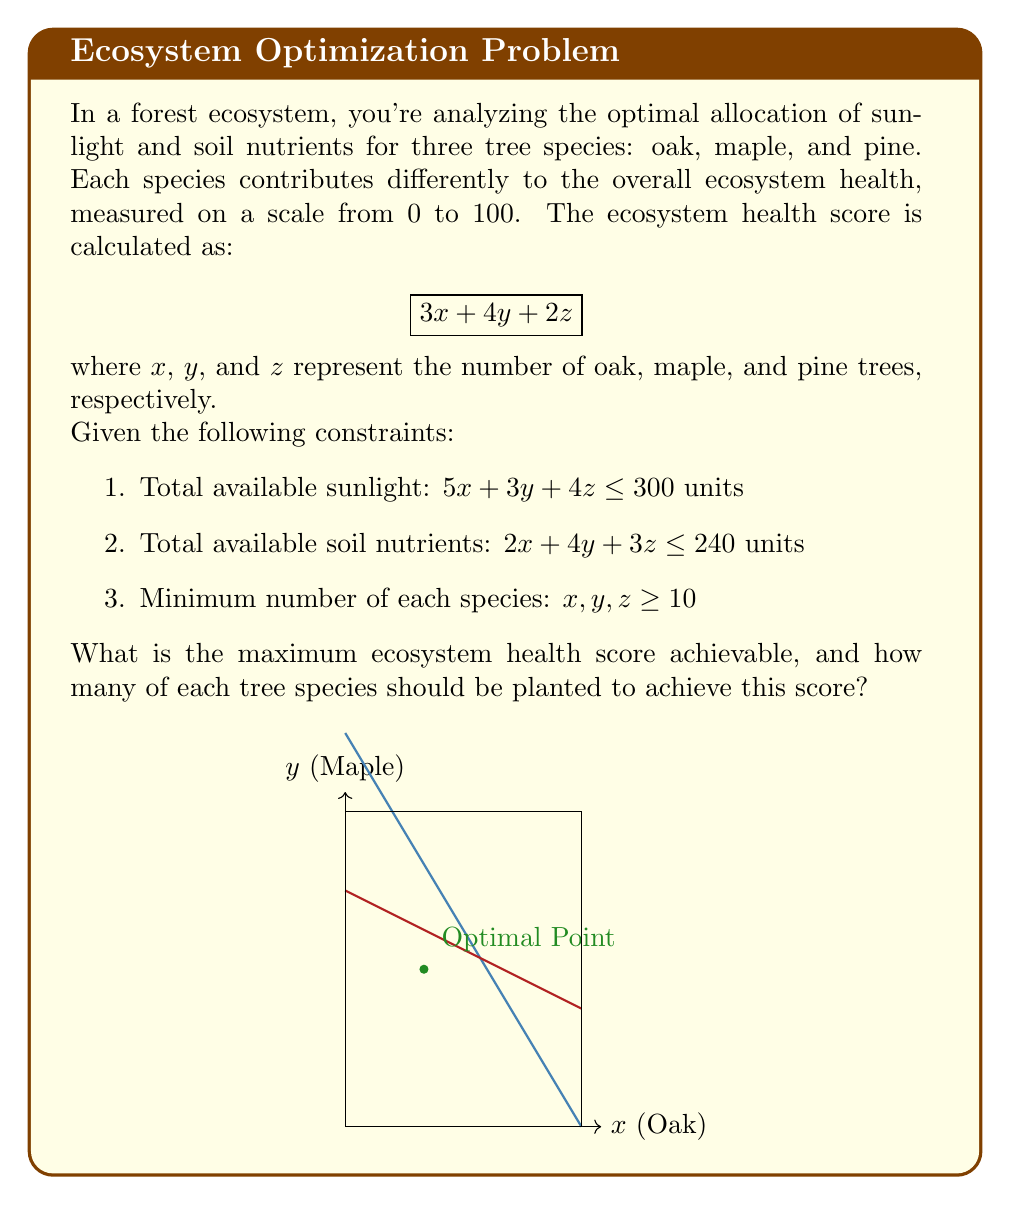Could you help me with this problem? To solve this linear programming problem, we'll follow these steps:

1) First, let's set up the objective function and constraints:

   Maximize: $3x + 4y + 2z$
   Subject to:
   $5x + 3y + 4z \leq 300$
   $2x + 4y + 3z \leq 240$
   $x, y, z \geq 10$

2) We can solve this using the simplex method, but for this explanation, we'll use a graphical approach focusing on the $x-y$ plane (oak-maple).

3) Let's graph the constraints:
   For $z = 10$ (minimum number of pine trees):
   $5x + 3y \leq 260$
   $2x + 4y \leq 210$

4) The feasible region is the area that satisfies all constraints. The optimal solution will be at one of the corners of this region.

5) The corners of the feasible region are:
   (10, 10), (20, 40), (42, 10), (10, 45)

6) Let's evaluate the objective function at each point (remember to add 20 for the 10 pine trees):
   (10, 10): $3(10) + 4(10) + 2(10) = 90$
   (20, 40): $3(20) + 4(40) + 2(10) = 240$
   (42, 10): $3(42) + 4(10) + 2(10) = 186$
   (10, 45): $3(10) + 4(45) + 2(10) = 230$

7) The maximum value is 240, achieved at the point (20, 40, 10).

Therefore, the optimal solution is to plant 20 oak trees, 40 maple trees, and 10 pine trees, resulting in a maximum ecosystem health score of 240.
Answer: 240; 20 oak, 40 maple, 10 pine 